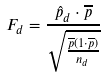Convert formula to latex. <formula><loc_0><loc_0><loc_500><loc_500>F _ { d } = \frac { \hat { p } _ { d } \cdot \overline { p } } { \sqrt { \frac { \overline { p } ( 1 \cdot \overline { p } ) } { n _ { d } } } }</formula> 